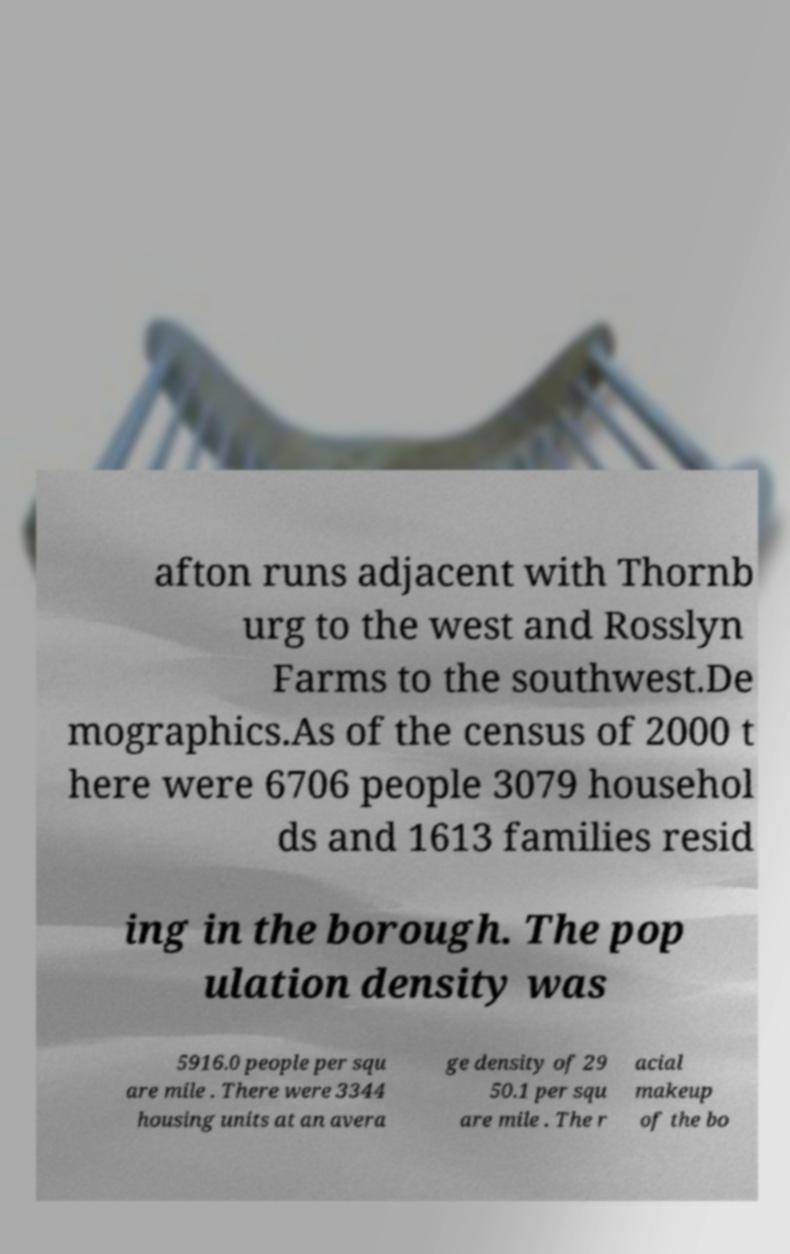Could you extract and type out the text from this image? afton runs adjacent with Thornb urg to the west and Rosslyn Farms to the southwest.De mographics.As of the census of 2000 t here were 6706 people 3079 househol ds and 1613 families resid ing in the borough. The pop ulation density was 5916.0 people per squ are mile . There were 3344 housing units at an avera ge density of 29 50.1 per squ are mile . The r acial makeup of the bo 